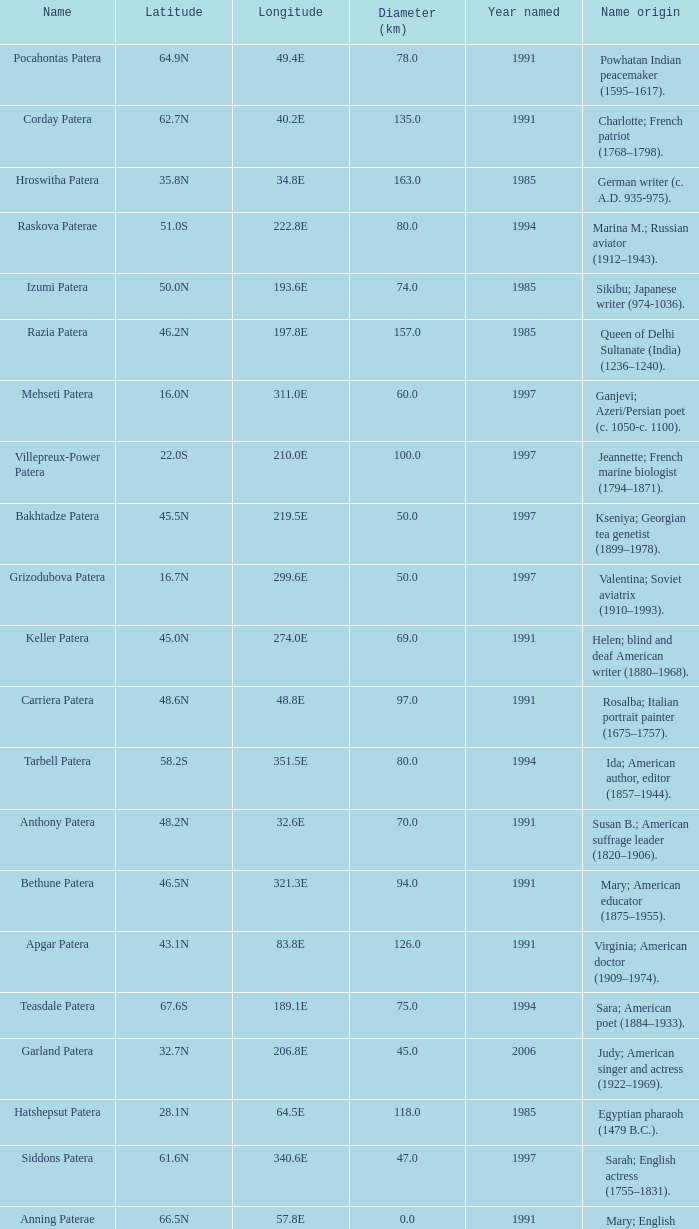What is the diameter in km of the feature named Colette Patera?  149.0. 